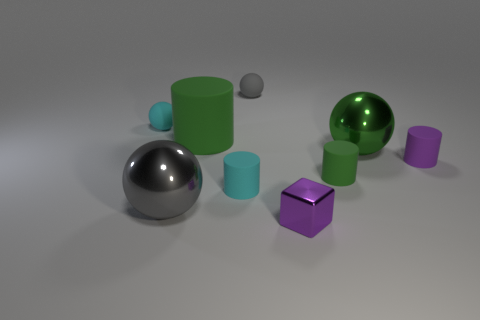Can you describe the arrangement of the objects in terms of proximity or layout? The objects are unevenly distributed, with some clustered closer together. For instance, two cylindrical shapes and a small sphere are grouped near the larger reflective sphere, while the cube shapes are spaced apart.  What could be the purpose of such an arrangement? This arrangement could be for a visual study of shapes, lighting, and reflections. It allows for observation of varying textures such as matte, reflective, and the effects of shadow and light on different geometrical forms. 